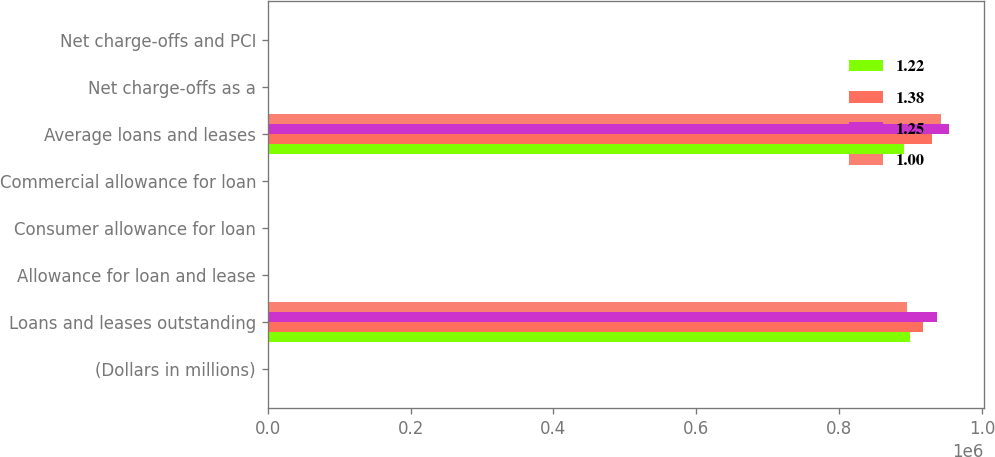<chart> <loc_0><loc_0><loc_500><loc_500><stacked_bar_chart><ecel><fcel>(Dollars in millions)<fcel>Loans and leases outstanding<fcel>Allowance for loan and lease<fcel>Consumer allowance for loan<fcel>Commercial allowance for loan<fcel>Average loans and leases<fcel>Net charge-offs as a<fcel>Net charge-offs and PCI<nl><fcel>1.22<fcel>2012<fcel>898817<fcel>2.69<fcel>3.81<fcel>0.9<fcel>890337<fcel>1.67<fcel>1.99<nl><fcel>1.38<fcel>2011<fcel>917396<fcel>3.68<fcel>4.88<fcel>1.33<fcel>929661<fcel>2.24<fcel>2.24<nl><fcel>1.25<fcel>2010<fcel>937119<fcel>4.47<fcel>5.4<fcel>2.44<fcel>954278<fcel>3.6<fcel>3.6<nl><fcel>1<fcel>2009<fcel>895192<fcel>4.16<fcel>4.81<fcel>2.96<fcel>941862<fcel>3.58<fcel>3.58<nl></chart> 